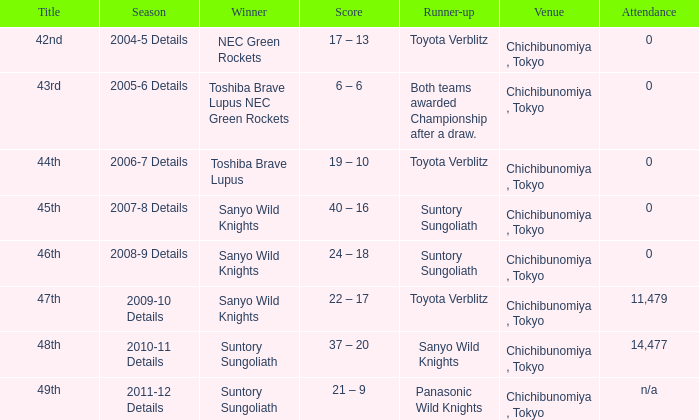What is the Attendance number when the runner-up was suntory sungoliath, and a Title of 46th? 0.0. 